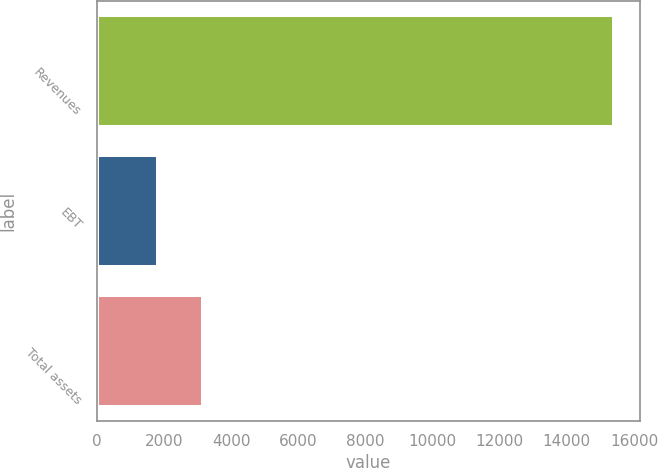<chart> <loc_0><loc_0><loc_500><loc_500><bar_chart><fcel>Revenues<fcel>EBT<fcel>Total assets<nl><fcel>15409<fcel>1812<fcel>3171.7<nl></chart> 